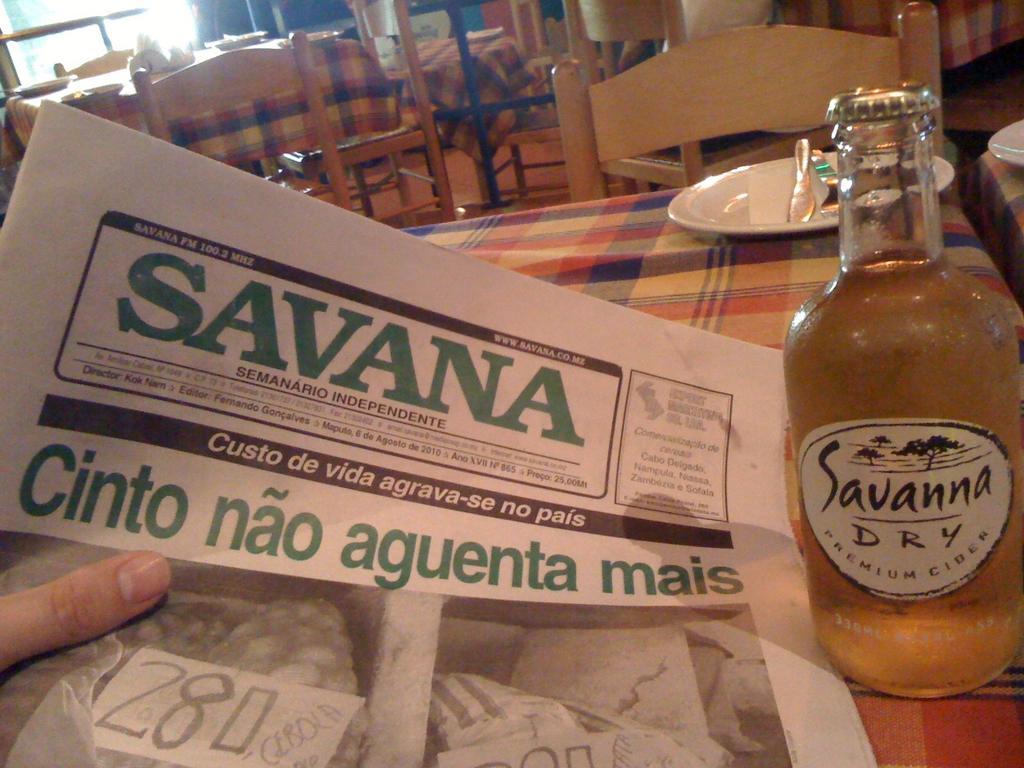Describe this image in one or two sentences. In this picture we can see table and on table we have bottle, plate and on plate knife, fork here person is holding paper and in background we can see table, chair, window, tissues. 